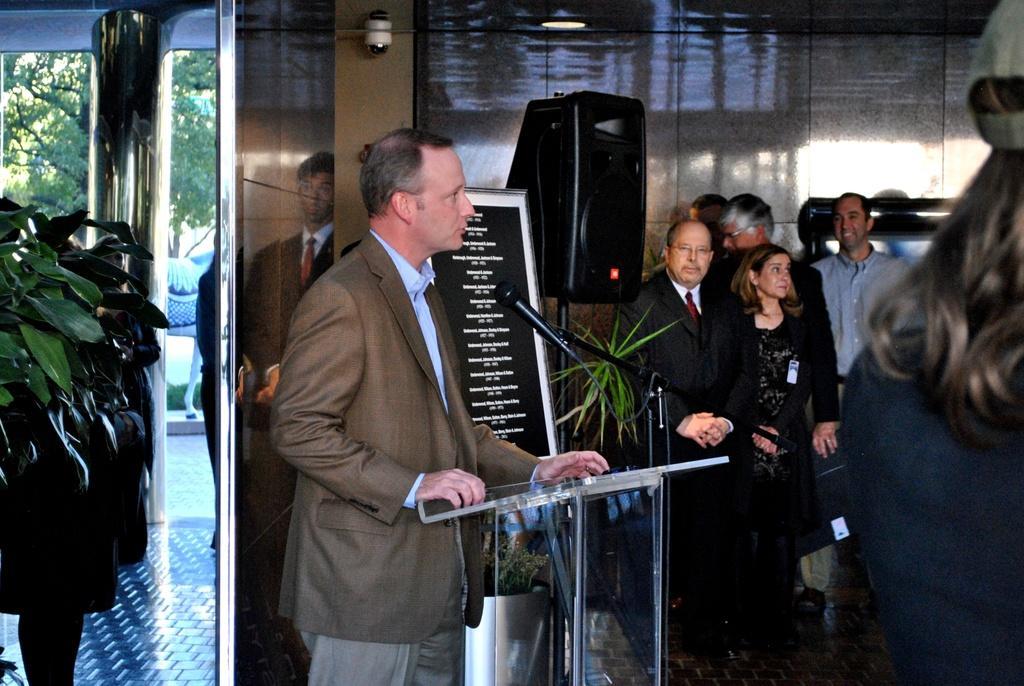In one or two sentences, can you explain what this image depicts? In the picture we can see a man standing and he is with blazer, shirt and talking in the microphone which is on the glass desk and front of him we can see some people are standing and listening and beside him we can also see a board with some names in it and a plant and on the left hand side we can see a mirror and a plant and in the background we can see some people and a sound box on the stand. 